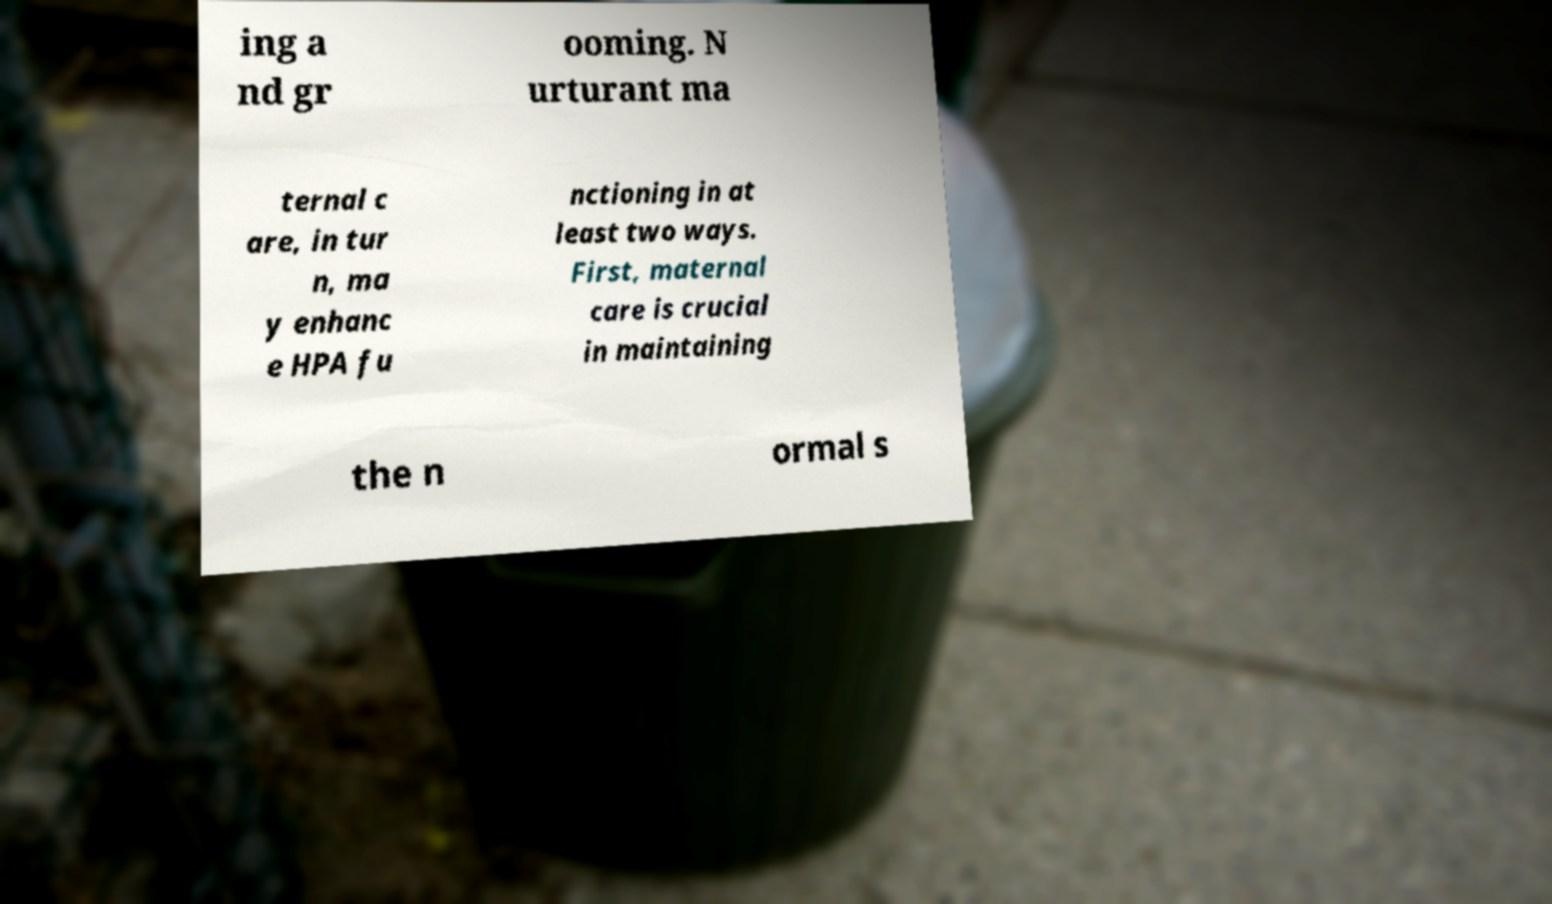What messages or text are displayed in this image? I need them in a readable, typed format. ing a nd gr ooming. N urturant ma ternal c are, in tur n, ma y enhanc e HPA fu nctioning in at least two ways. First, maternal care is crucial in maintaining the n ormal s 